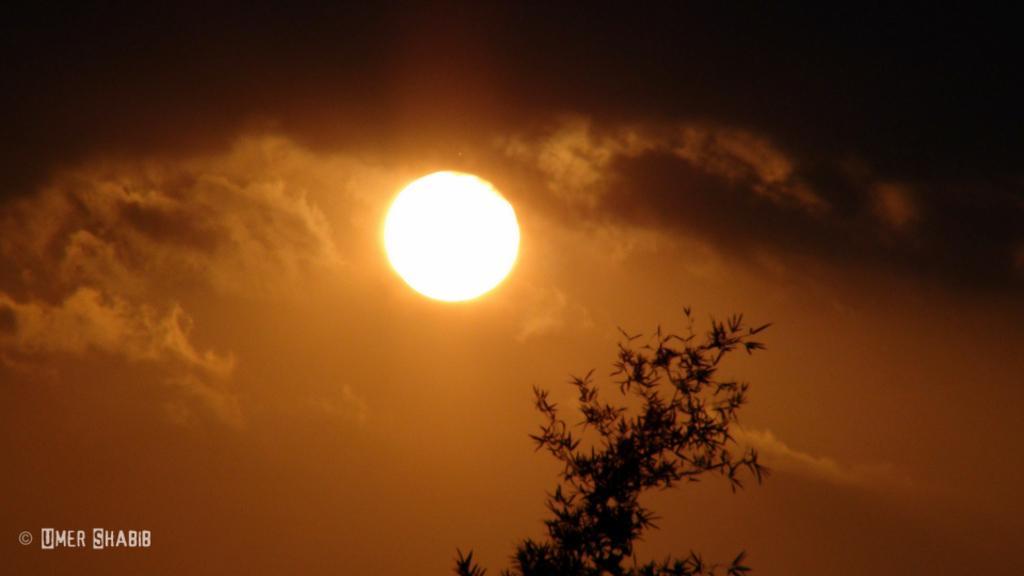Describe this image in one or two sentences. In this image I see the sun over here and I see the clouds and I see the leaves over here and I see the watermark over here. 